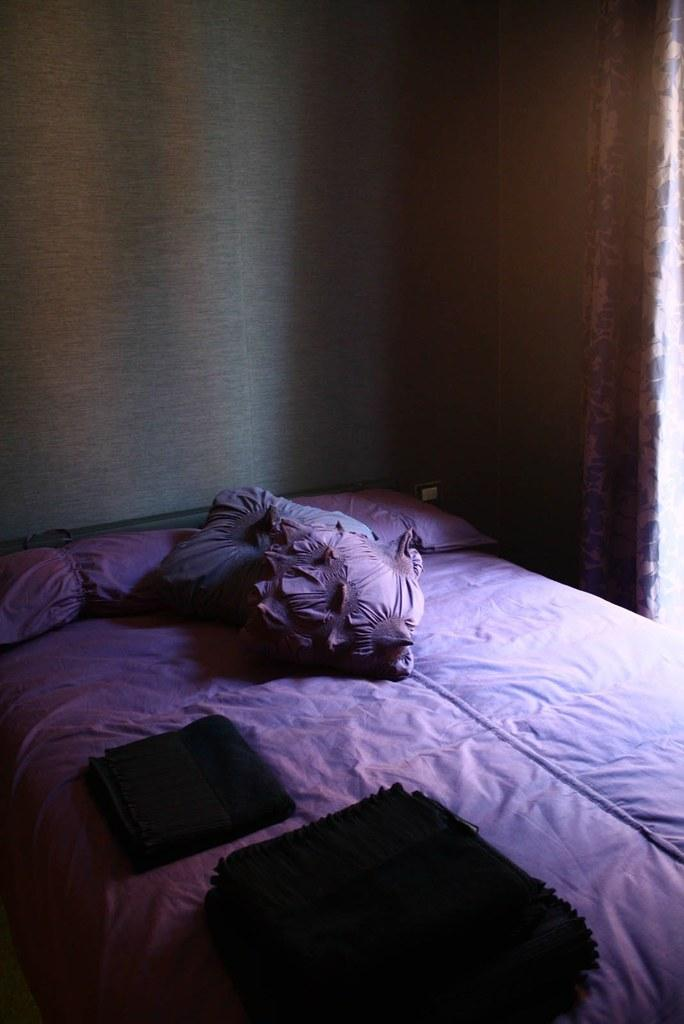What type of furniture is present in the image? There is a bed in the image. What is placed on the bed? There are pillows on the bed. Can you describe any objects in the image that have a specific color? Yes, there are objects in the image that are black in color. What is located on the right side of the image? There is a curtain on the right side of the image. What type of weather can be seen in the image? There is no weather visible in the image, as it is an indoor scene with a bed, pillows, black objects, and a curtain. 